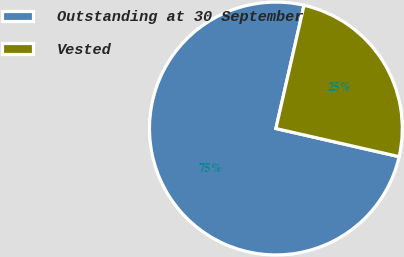Convert chart to OTSL. <chart><loc_0><loc_0><loc_500><loc_500><pie_chart><fcel>Outstanding at 30 September<fcel>Vested<nl><fcel>75.0%<fcel>25.0%<nl></chart> 